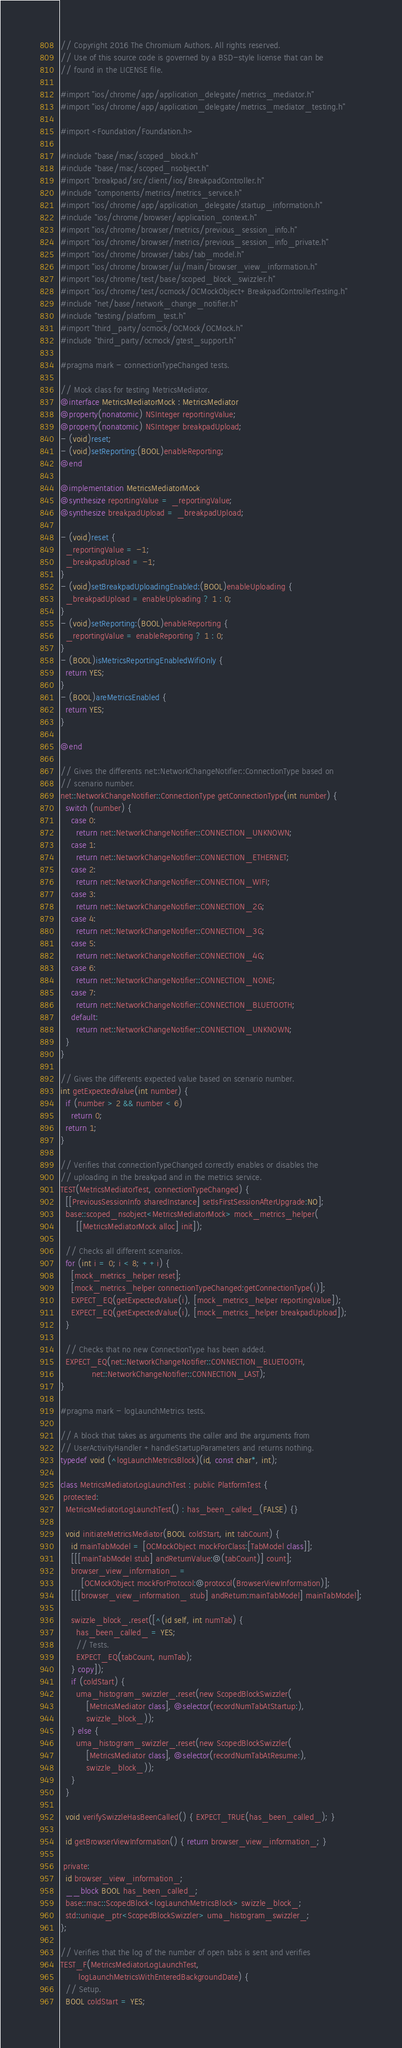<code> <loc_0><loc_0><loc_500><loc_500><_ObjectiveC_>// Copyright 2016 The Chromium Authors. All rights reserved.
// Use of this source code is governed by a BSD-style license that can be
// found in the LICENSE file.

#import "ios/chrome/app/application_delegate/metrics_mediator.h"
#import "ios/chrome/app/application_delegate/metrics_mediator_testing.h"

#import <Foundation/Foundation.h>

#include "base/mac/scoped_block.h"
#include "base/mac/scoped_nsobject.h"
#import "breakpad/src/client/ios/BreakpadController.h"
#include "components/metrics/metrics_service.h"
#import "ios/chrome/app/application_delegate/startup_information.h"
#include "ios/chrome/browser/application_context.h"
#import "ios/chrome/browser/metrics/previous_session_info.h"
#import "ios/chrome/browser/metrics/previous_session_info_private.h"
#import "ios/chrome/browser/tabs/tab_model.h"
#import "ios/chrome/browser/ui/main/browser_view_information.h"
#import "ios/chrome/test/base/scoped_block_swizzler.h"
#import "ios/chrome/test/ocmock/OCMockObject+BreakpadControllerTesting.h"
#include "net/base/network_change_notifier.h"
#include "testing/platform_test.h"
#import "third_party/ocmock/OCMock/OCMock.h"
#include "third_party/ocmock/gtest_support.h"

#pragma mark - connectionTypeChanged tests.

// Mock class for testing MetricsMediator.
@interface MetricsMediatorMock : MetricsMediator
@property(nonatomic) NSInteger reportingValue;
@property(nonatomic) NSInteger breakpadUpload;
- (void)reset;
- (void)setReporting:(BOOL)enableReporting;
@end

@implementation MetricsMediatorMock
@synthesize reportingValue = _reportingValue;
@synthesize breakpadUpload = _breakpadUpload;

- (void)reset {
  _reportingValue = -1;
  _breakpadUpload = -1;
}
- (void)setBreakpadUploadingEnabled:(BOOL)enableUploading {
  _breakpadUpload = enableUploading ? 1 : 0;
}
- (void)setReporting:(BOOL)enableReporting {
  _reportingValue = enableReporting ? 1 : 0;
}
- (BOOL)isMetricsReportingEnabledWifiOnly {
  return YES;
}
- (BOOL)areMetricsEnabled {
  return YES;
}

@end

// Gives the differents net::NetworkChangeNotifier::ConnectionType based on
// scenario number.
net::NetworkChangeNotifier::ConnectionType getConnectionType(int number) {
  switch (number) {
    case 0:
      return net::NetworkChangeNotifier::CONNECTION_UNKNOWN;
    case 1:
      return net::NetworkChangeNotifier::CONNECTION_ETHERNET;
    case 2:
      return net::NetworkChangeNotifier::CONNECTION_WIFI;
    case 3:
      return net::NetworkChangeNotifier::CONNECTION_2G;
    case 4:
      return net::NetworkChangeNotifier::CONNECTION_3G;
    case 5:
      return net::NetworkChangeNotifier::CONNECTION_4G;
    case 6:
      return net::NetworkChangeNotifier::CONNECTION_NONE;
    case 7:
      return net::NetworkChangeNotifier::CONNECTION_BLUETOOTH;
    default:
      return net::NetworkChangeNotifier::CONNECTION_UNKNOWN;
  }
}

// Gives the differents expected value based on scenario number.
int getExpectedValue(int number) {
  if (number > 2 && number < 6)
    return 0;
  return 1;
}

// Verifies that connectionTypeChanged correctly enables or disables the
// uploading in the breakpad and in the metrics service.
TEST(MetricsMediatorTest, connectionTypeChanged) {
  [[PreviousSessionInfo sharedInstance] setIsFirstSessionAfterUpgrade:NO];
  base::scoped_nsobject<MetricsMediatorMock> mock_metrics_helper(
      [[MetricsMediatorMock alloc] init]);

  // Checks all different scenarios.
  for (int i = 0; i < 8; ++i) {
    [mock_metrics_helper reset];
    [mock_metrics_helper connectionTypeChanged:getConnectionType(i)];
    EXPECT_EQ(getExpectedValue(i), [mock_metrics_helper reportingValue]);
    EXPECT_EQ(getExpectedValue(i), [mock_metrics_helper breakpadUpload]);
  }

  // Checks that no new ConnectionType has been added.
  EXPECT_EQ(net::NetworkChangeNotifier::CONNECTION_BLUETOOTH,
            net::NetworkChangeNotifier::CONNECTION_LAST);
}

#pragma mark - logLaunchMetrics tests.

// A block that takes as arguments the caller and the arguments from
// UserActivityHandler +handleStartupParameters and returns nothing.
typedef void (^logLaunchMetricsBlock)(id, const char*, int);

class MetricsMediatorLogLaunchTest : public PlatformTest {
 protected:
  MetricsMediatorLogLaunchTest() : has_been_called_(FALSE) {}

  void initiateMetricsMediator(BOOL coldStart, int tabCount) {
    id mainTabModel = [OCMockObject mockForClass:[TabModel class]];
    [[[mainTabModel stub] andReturnValue:@(tabCount)] count];
    browser_view_information_ =
        [OCMockObject mockForProtocol:@protocol(BrowserViewInformation)];
    [[[browser_view_information_ stub] andReturn:mainTabModel] mainTabModel];

    swizzle_block_.reset([^(id self, int numTab) {
      has_been_called_ = YES;
      // Tests.
      EXPECT_EQ(tabCount, numTab);
    } copy]);
    if (coldStart) {
      uma_histogram_swizzler_.reset(new ScopedBlockSwizzler(
          [MetricsMediator class], @selector(recordNumTabAtStartup:),
          swizzle_block_));
    } else {
      uma_histogram_swizzler_.reset(new ScopedBlockSwizzler(
          [MetricsMediator class], @selector(recordNumTabAtResume:),
          swizzle_block_));
    }
  }

  void verifySwizzleHasBeenCalled() { EXPECT_TRUE(has_been_called_); }

  id getBrowserViewInformation() { return browser_view_information_; }

 private:
  id browser_view_information_;
  __block BOOL has_been_called_;
  base::mac::ScopedBlock<logLaunchMetricsBlock> swizzle_block_;
  std::unique_ptr<ScopedBlockSwizzler> uma_histogram_swizzler_;
};

// Verifies that the log of the number of open tabs is sent and verifies
TEST_F(MetricsMediatorLogLaunchTest,
       logLaunchMetricsWithEnteredBackgroundDate) {
  // Setup.
  BOOL coldStart = YES;</code> 